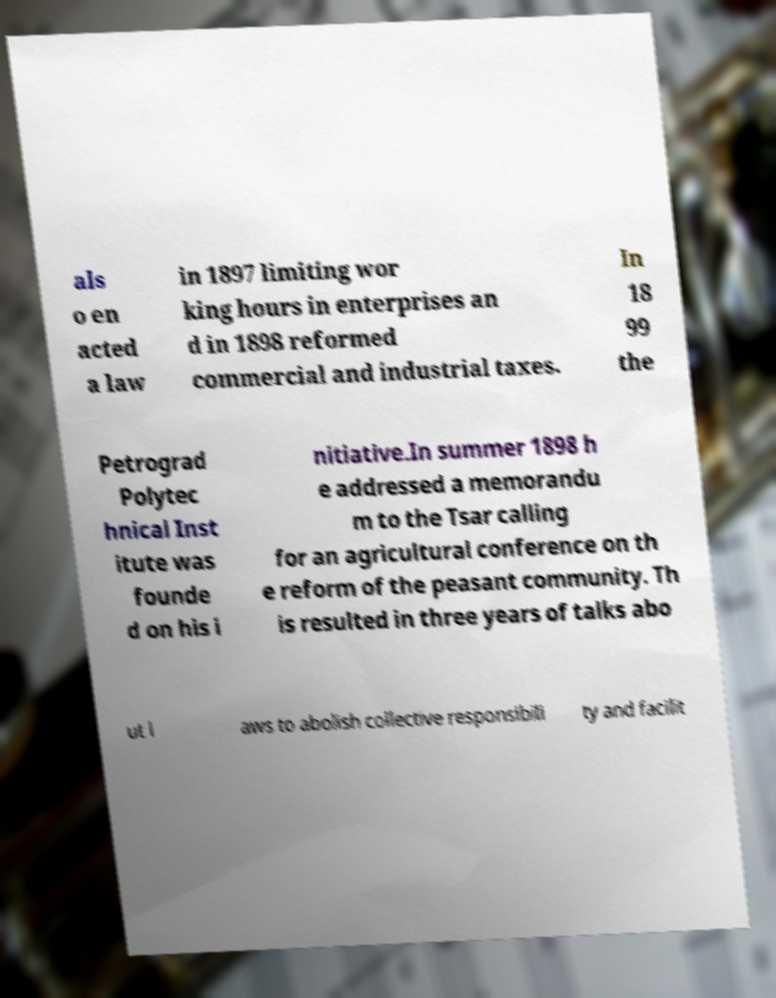There's text embedded in this image that I need extracted. Can you transcribe it verbatim? als o en acted a law in 1897 limiting wor king hours in enterprises an d in 1898 reformed commercial and industrial taxes. In 18 99 the Petrograd Polytec hnical Inst itute was founde d on his i nitiative.In summer 1898 h e addressed a memorandu m to the Tsar calling for an agricultural conference on th e reform of the peasant community. Th is resulted in three years of talks abo ut l aws to abolish collective responsibili ty and facilit 